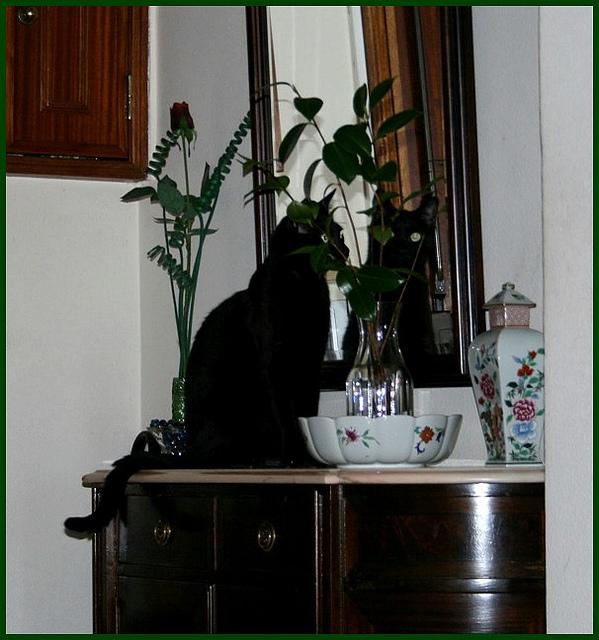Is this in a bedroom?
Short answer required. No. What is the cat looking at?
Quick response, please. Plant. Is there an animal in the picture?
Be succinct. Yes. 